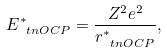<formula> <loc_0><loc_0><loc_500><loc_500>E _ { \ t n { O C P } } ^ { * } = \frac { Z ^ { 2 } e ^ { 2 } } { r _ { \ t n { O C P } } ^ { * } } ,</formula> 